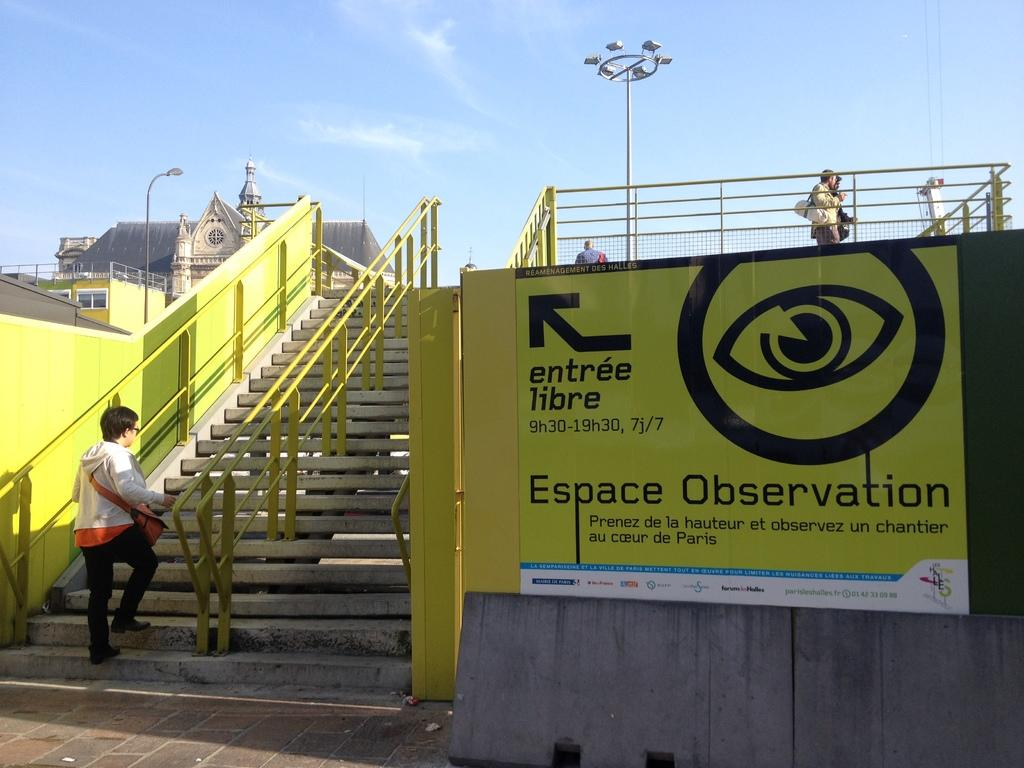What is the person in the image doing? There is a person climbing the stairs in the image. What can be seen in the background of the image? There are lamp posts and a building in the background of the image. How many bears are visible on the sheet in the image? There are no bears or sheets present in the image. 